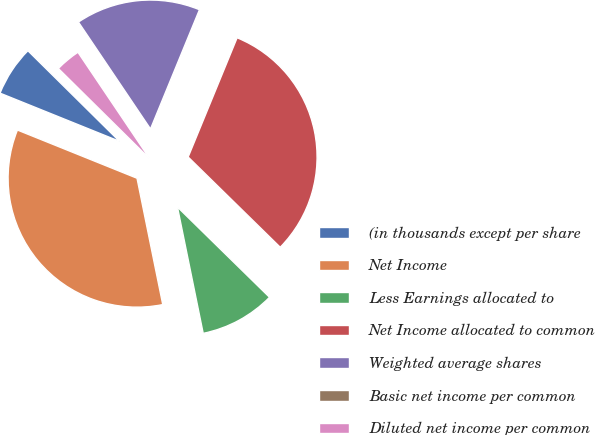Convert chart to OTSL. <chart><loc_0><loc_0><loc_500><loc_500><pie_chart><fcel>(in thousands except per share<fcel>Net Income<fcel>Less Earnings allocated to<fcel>Net Income allocated to common<fcel>Weighted average shares<fcel>Basic net income per common<fcel>Diluted net income per common<nl><fcel>6.31%<fcel>34.3%<fcel>9.46%<fcel>31.14%<fcel>15.64%<fcel>0.0%<fcel>3.15%<nl></chart> 